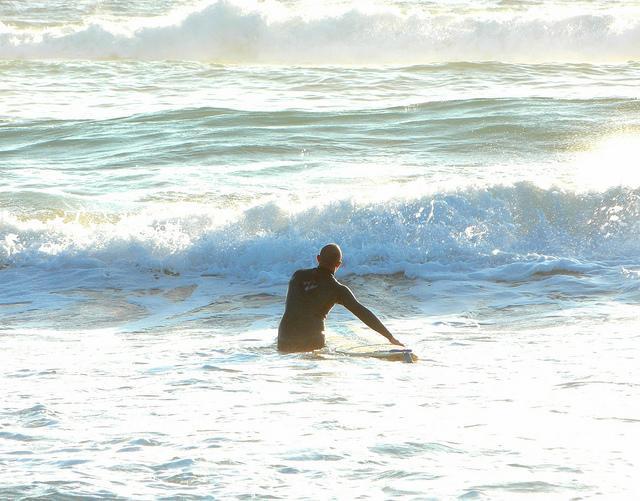How many people are wearing orange vests?
Give a very brief answer. 0. 